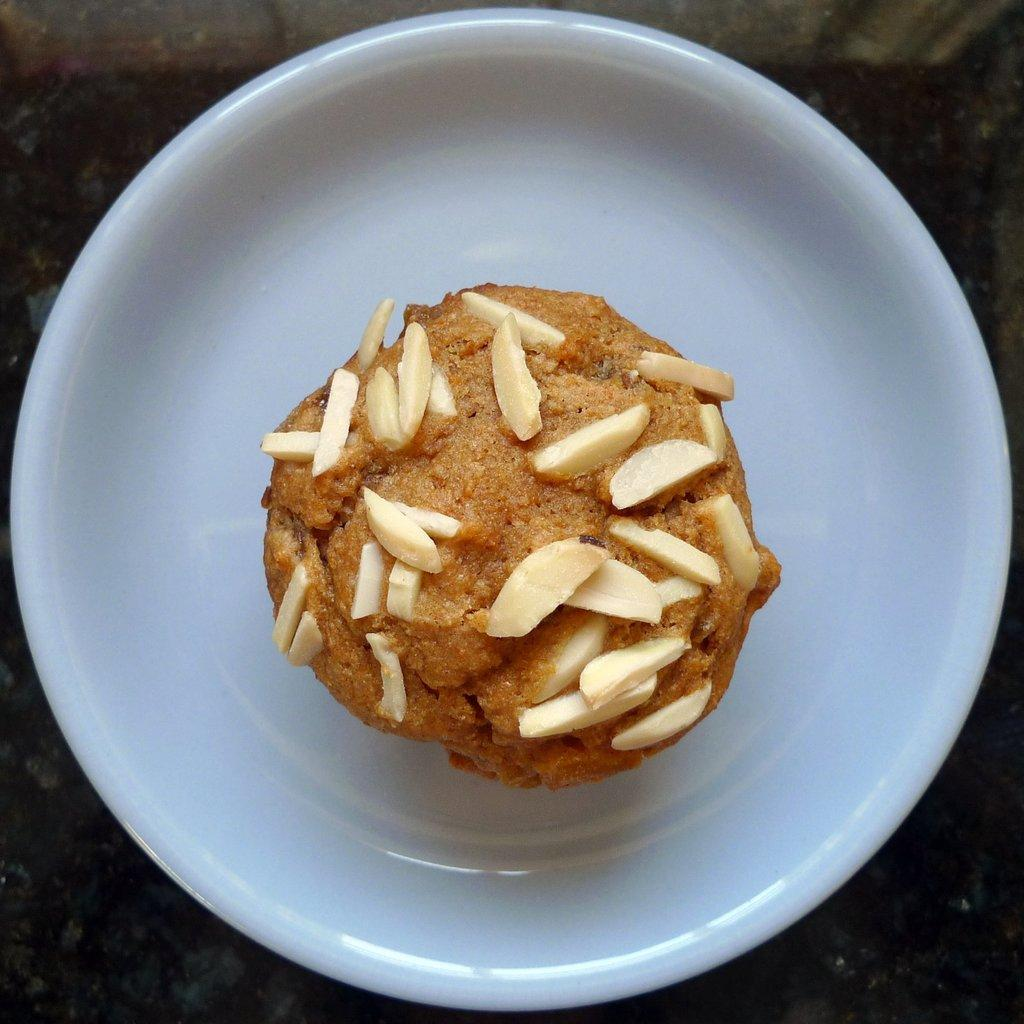What type of food is visible in the image? There is a cupcake in the image. What is the cupcake placed on? The cupcake is on a white plate. What color is the surface the white plate is placed on? The white plate is placed on a black surface. What type of curtain can be seen hanging from the back of the bed in the image? There is no curtain or bed present in the image; it only features a cupcake on a white plate placed on a black surface. 